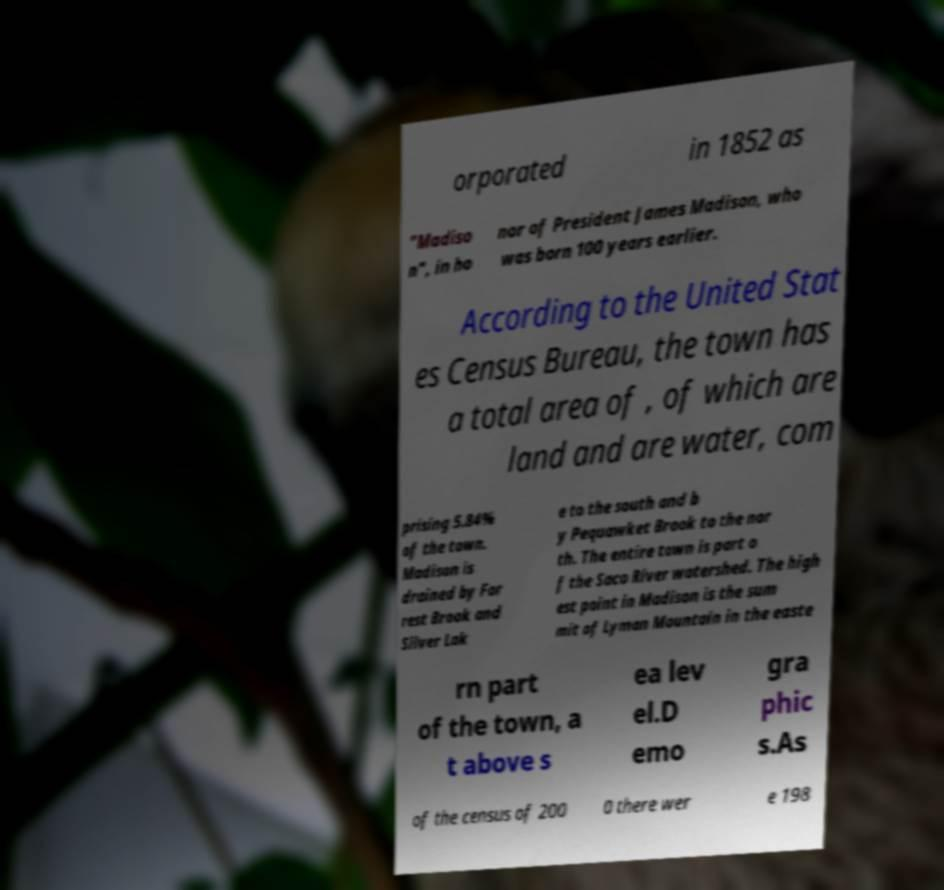Please identify and transcribe the text found in this image. orporated in 1852 as "Madiso n", in ho nor of President James Madison, who was born 100 years earlier. According to the United Stat es Census Bureau, the town has a total area of , of which are land and are water, com prising 5.84% of the town. Madison is drained by For rest Brook and Silver Lak e to the south and b y Pequawket Brook to the nor th. The entire town is part o f the Saco River watershed. The high est point in Madison is the sum mit of Lyman Mountain in the easte rn part of the town, a t above s ea lev el.D emo gra phic s.As of the census of 200 0 there wer e 198 